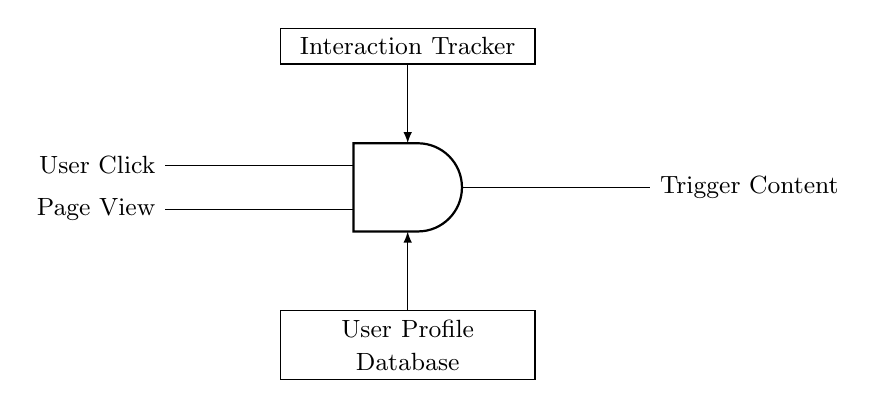What are the two inputs of the AND gate? The AND gate has two inputs, represented in the circuit as "User Click" and "Page View." These are the signals that affect the output of the gate.
Answer: User Click, Page View What is the output of the AND gate? The output of the AND gate is labeled as "Trigger Content" in the circuit. This means that the output will be activated only when both inputs are present.
Answer: Trigger Content What does the interaction tracker do in this circuit? The interaction tracker is involved in monitoring user behavior, sending its signal to the AND gate to help determine if content should be triggered.
Answer: Monitors user behavior How many components are connected to the AND gate? There are four components connected to the AND gate: two inputs (User Click and Page View), one output (Trigger Content), and two additional rectangles (Interaction Tracker and User Profile Database) connected to the AND gate.
Answer: Four components What does the User Profile Database indicate in the circuit? The User Profile Database indicates where user information is stored and from where it feeds data into the AND gate, influencing the interaction process.
Answer: Stores user information What logic does the AND gate implement in this setup? The AND gate implements logical conjunction, meaning it will output a signal (Trigger Content) only when both of its inputs (User Click and Page View) are true (active).
Answer: Logical conjunction 